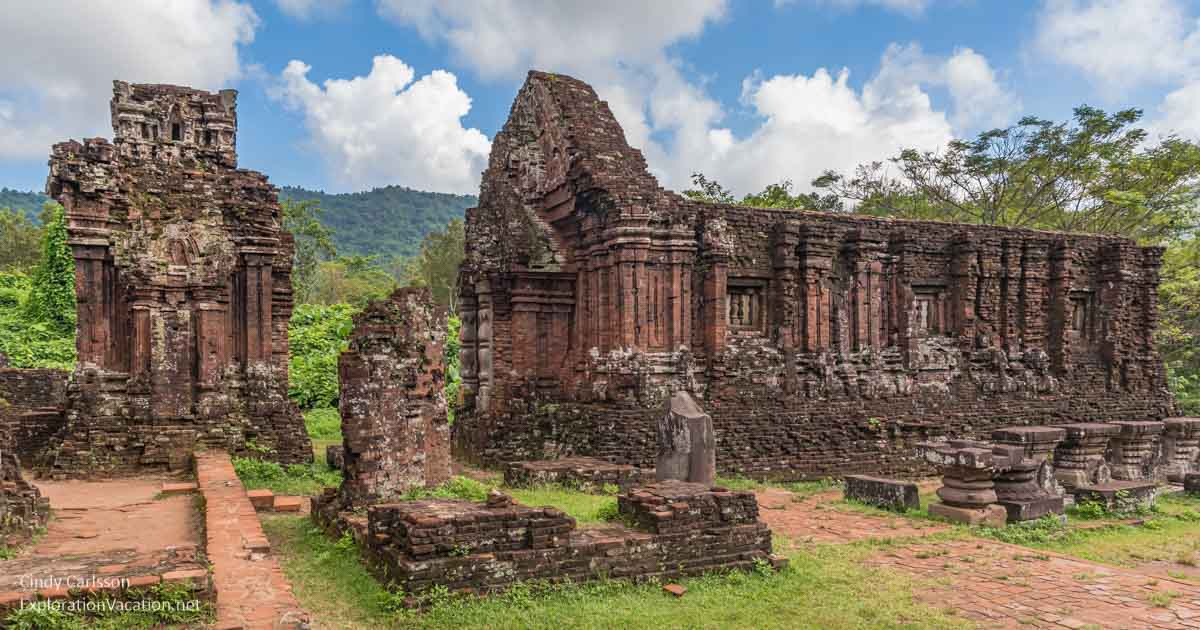Explain the visual content of the image in great detail. The image vividly captures the ancient My Son temple complex in Vietnam, revealing the intricate structures built from red brick. These structures, distinct in their architectural heritage influenced by Indian civilization, stand partially in ruins yet retain a dignified grandeur. Positioned amidst a dense green jungle, the setting includes young trees and overgrown grass between stone pathways, hinting at nature's reclamation. Distant hills envelope the site, with a clear sky overhead punctuated by wispy clouds, framing this majestic historical site in a natural tableau that emphasizes both its past glory and present mystique. Enhancing the description, the temples are characterized by detailed carvings and motifs typical of the Hindu temple architecture dedicated to various deities, reflecting the cultural and religious significance that permeated through these ruins across centuries. 